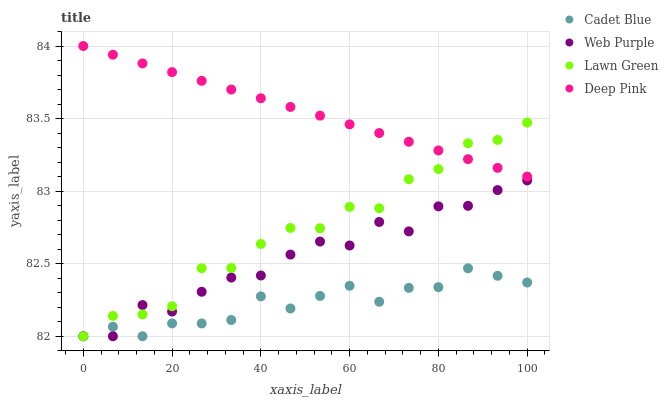Does Cadet Blue have the minimum area under the curve?
Answer yes or no. Yes. Does Deep Pink have the maximum area under the curve?
Answer yes or no. Yes. Does Web Purple have the minimum area under the curve?
Answer yes or no. No. Does Web Purple have the maximum area under the curve?
Answer yes or no. No. Is Deep Pink the smoothest?
Answer yes or no. Yes. Is Web Purple the roughest?
Answer yes or no. Yes. Is Cadet Blue the smoothest?
Answer yes or no. No. Is Cadet Blue the roughest?
Answer yes or no. No. Does Lawn Green have the lowest value?
Answer yes or no. Yes. Does Deep Pink have the lowest value?
Answer yes or no. No. Does Deep Pink have the highest value?
Answer yes or no. Yes. Does Web Purple have the highest value?
Answer yes or no. No. Is Web Purple less than Deep Pink?
Answer yes or no. Yes. Is Deep Pink greater than Cadet Blue?
Answer yes or no. Yes. Does Cadet Blue intersect Lawn Green?
Answer yes or no. Yes. Is Cadet Blue less than Lawn Green?
Answer yes or no. No. Is Cadet Blue greater than Lawn Green?
Answer yes or no. No. Does Web Purple intersect Deep Pink?
Answer yes or no. No. 